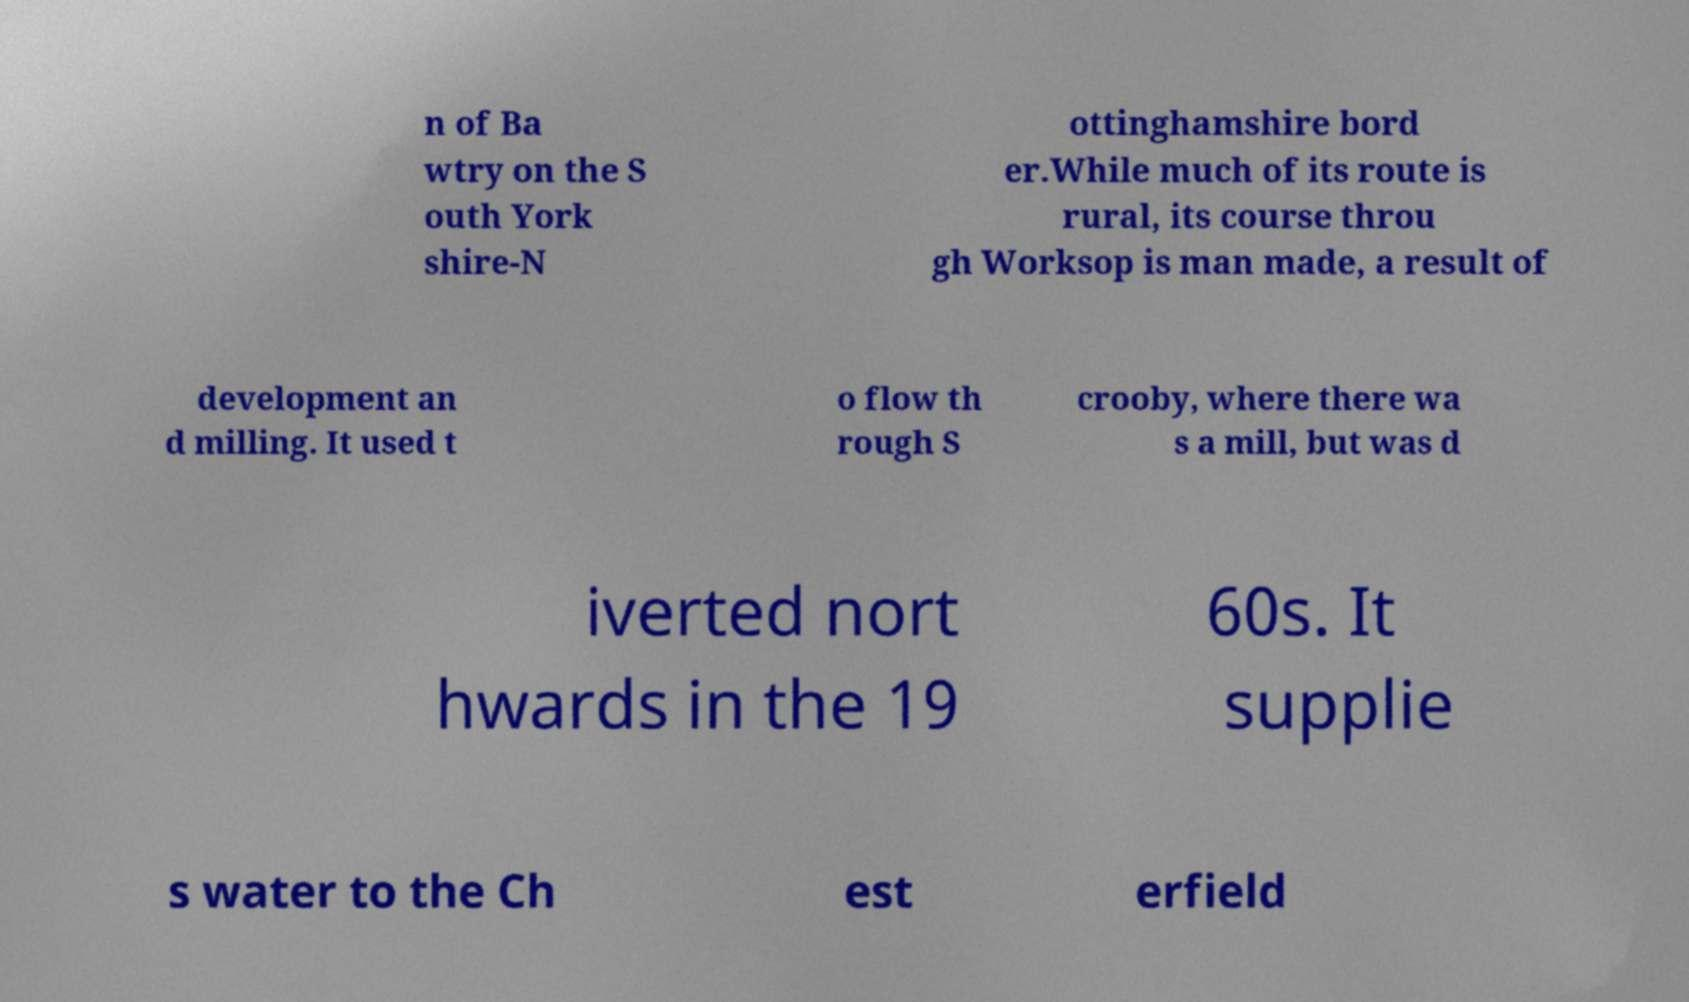Can you read and provide the text displayed in the image?This photo seems to have some interesting text. Can you extract and type it out for me? n of Ba wtry on the S outh York shire-N ottinghamshire bord er.While much of its route is rural, its course throu gh Worksop is man made, a result of development an d milling. It used t o flow th rough S crooby, where there wa s a mill, but was d iverted nort hwards in the 19 60s. It supplie s water to the Ch est erfield 